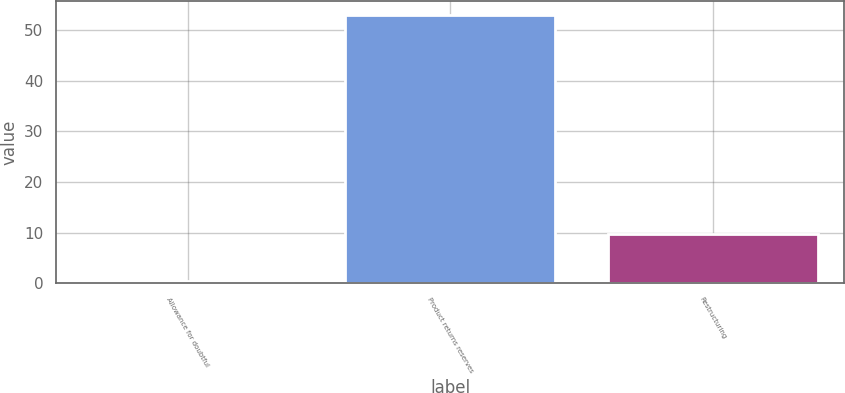Convert chart. <chart><loc_0><loc_0><loc_500><loc_500><bar_chart><fcel>Allowance for doubtful<fcel>Product returns reserves<fcel>Restructuring<nl><fcel>0.4<fcel>53.1<fcel>9.8<nl></chart> 